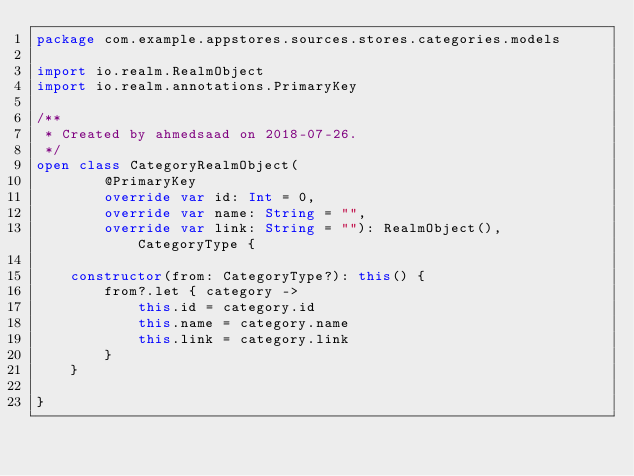Convert code to text. <code><loc_0><loc_0><loc_500><loc_500><_Kotlin_>package com.example.appstores.sources.stores.categories.models

import io.realm.RealmObject
import io.realm.annotations.PrimaryKey

/**
 * Created by ahmedsaad on 2018-07-26.
 */
open class CategoryRealmObject(
        @PrimaryKey
        override var id: Int = 0,
        override var name: String = "",
        override var link: String = ""): RealmObject(), CategoryType {

    constructor(from: CategoryType?): this() {
        from?.let { category ->
            this.id = category.id
            this.name = category.name
            this.link = category.link
        }
    }

}</code> 